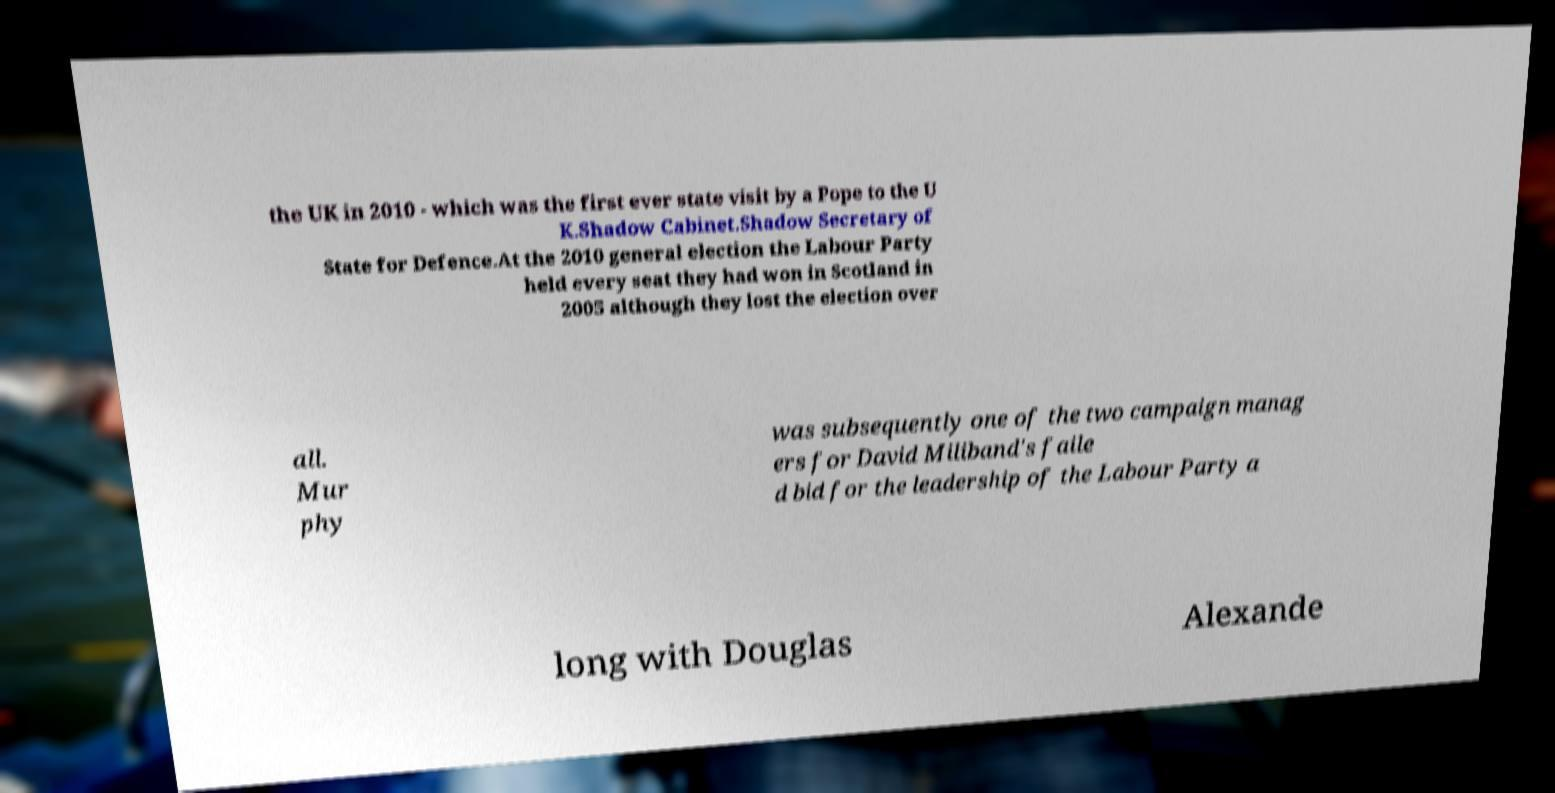Please identify and transcribe the text found in this image. the UK in 2010 - which was the first ever state visit by a Pope to the U K.Shadow Cabinet.Shadow Secretary of State for Defence.At the 2010 general election the Labour Party held every seat they had won in Scotland in 2005 although they lost the election over all. Mur phy was subsequently one of the two campaign manag ers for David Miliband's faile d bid for the leadership of the Labour Party a long with Douglas Alexande 